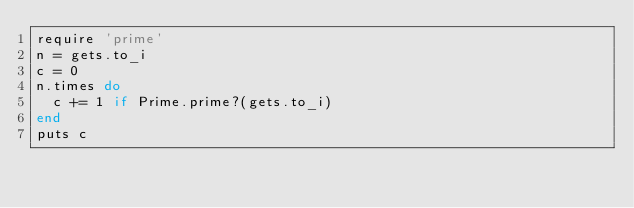Convert code to text. <code><loc_0><loc_0><loc_500><loc_500><_Ruby_>require 'prime'
n = gets.to_i
c = 0
n.times do
  c += 1 if Prime.prime?(gets.to_i)
end
puts c

</code> 